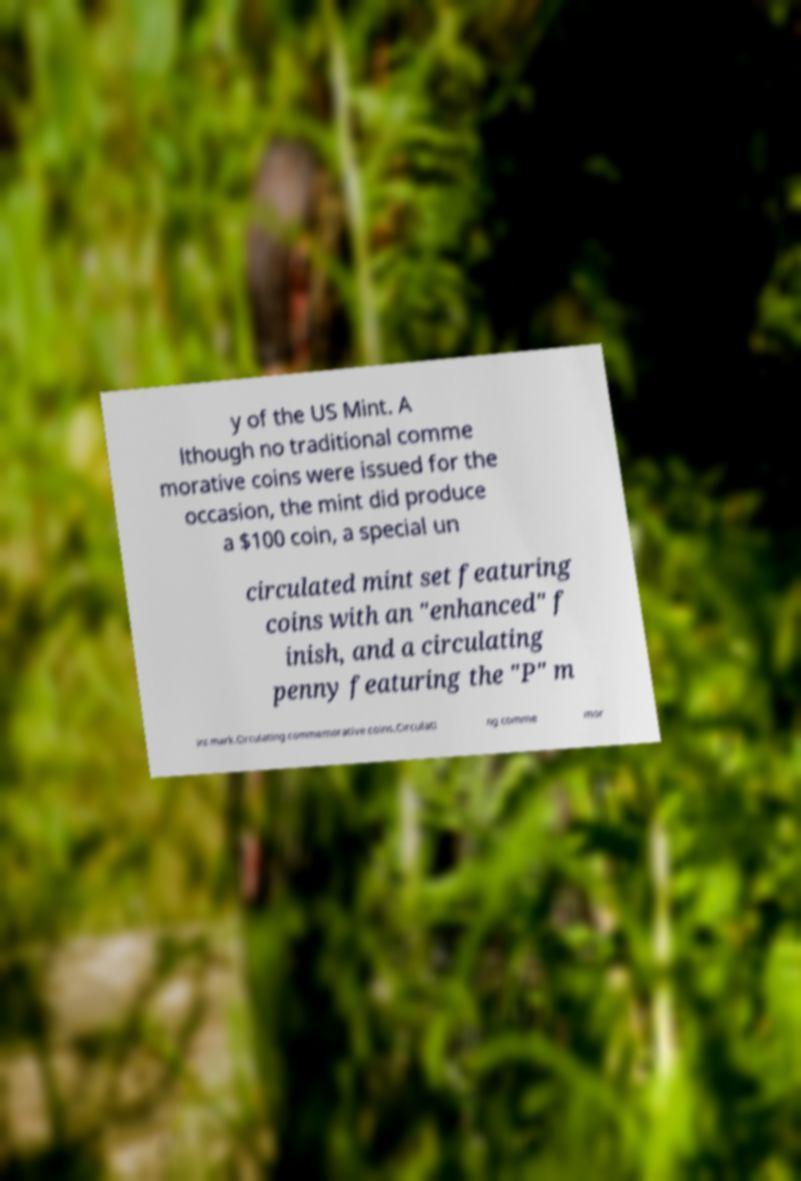Could you assist in decoding the text presented in this image and type it out clearly? y of the US Mint. A lthough no traditional comme morative coins were issued for the occasion, the mint did produce a $100 coin, a special un circulated mint set featuring coins with an "enhanced" f inish, and a circulating penny featuring the "P" m int mark.Circulating commemorative coins.Circulati ng comme mor 